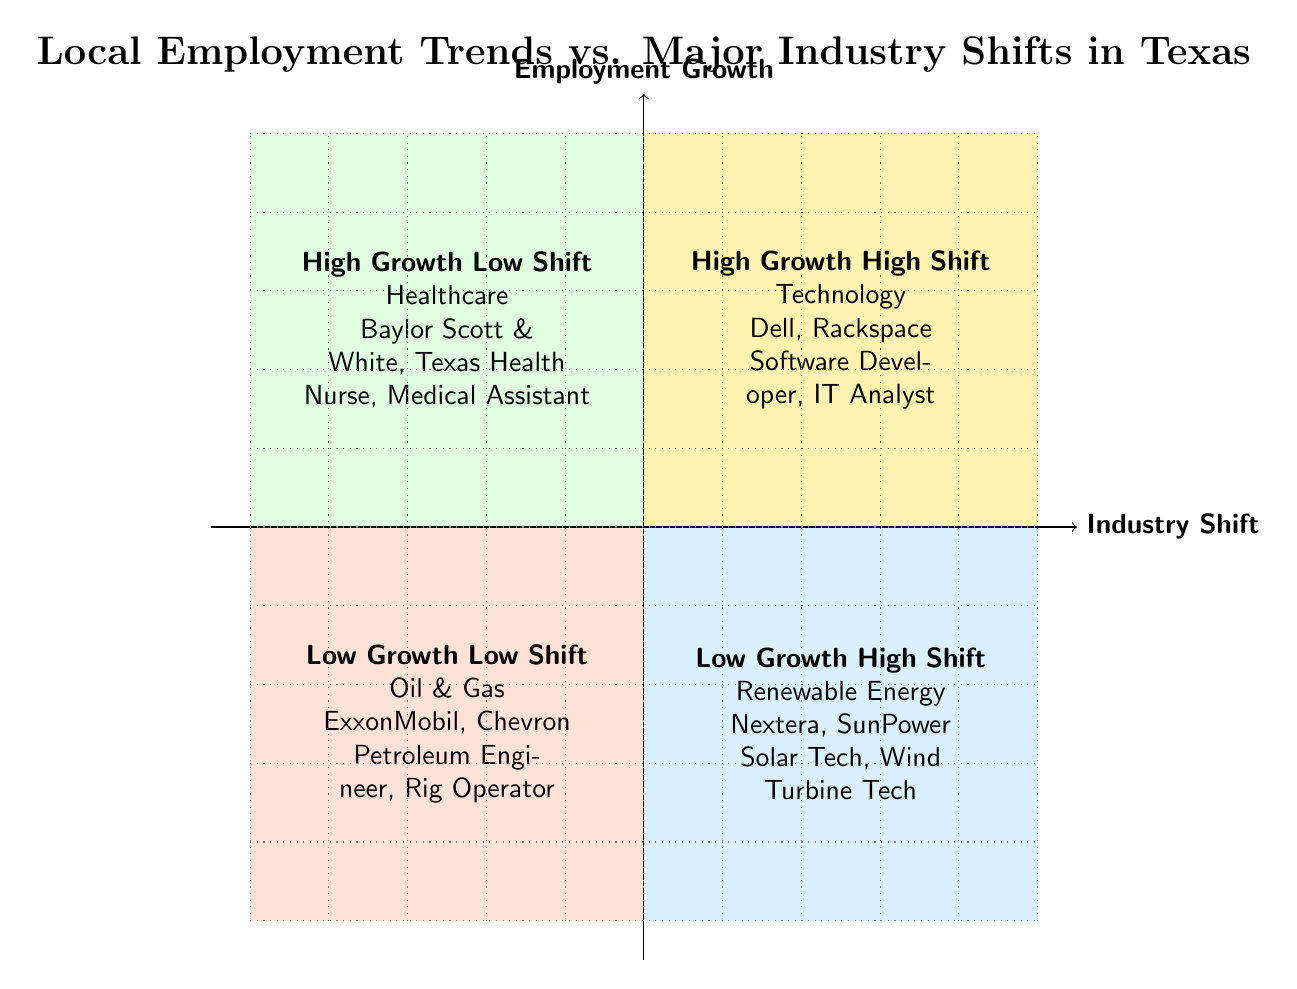What industry is in the High Growth Low Shift quadrant? The diagram indicates that the industry in the High Growth Low Shift quadrant is Healthcare.
Answer: Healthcare Which industry has example companies like Nextera Energy Resources? According to the diagram, Nextera Energy Resources is an example company in the Renewable Energy industry, which is located in the Low Growth High Shift quadrant.
Answer: Renewable Energy How many job roles are listed for the Oil & Gas industry? The Oil & Gas industry in the Low Growth Low Shift quadrant lists two job roles: Petroleum Engineer and Rig Operator. Therefore, the total number of job roles is two.
Answer: 2 What is the primary characteristic of the Technology industry as represented in the diagram? The Technology industry is positioned in the High Growth High Shift quadrant, indicating both a high growth in employment and a significant shift in industry.
Answer: High Growth High Shift Which quadrant contains the Oil & Gas industry? The diagram shows that the Oil & Gas industry is located in the Low Growth Low Shift quadrant, indicating limited employment growth alongside minimal industry shifts.
Answer: Low Growth Low Shift What job roles are associated with the Renewable Energy industry? The Renewable Energy industry is associated with the job roles of Solar Technician and Wind Turbine Service Technician, as indicated in the Low Growth High Shift quadrant.
Answer: Solar Technician, Wind Turbine Service Technician Name one company from the Healthcare sector. One of the companies in the Healthcare sector, as shown in the High Growth Low Shift quadrant, is Baylor Scott & White Health.
Answer: Baylor Scott & White Health Which quadrant has the least employment growth according to the diagram? The diagram illustrates that the quadrant with the least employment growth is the Low Growth Low Shift quadrant, where the Oil & Gas industry is located.
Answer: Low Growth Low Shift What role is highlighted in the Technology sector? In the Technology sector, one of the highlighted job roles is Software Developer, which is part of the High Growth High Shift quadrant.
Answer: Software Developer 